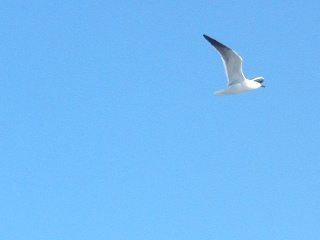How is the weather? The weather appears to be clear and cloudless, with bright blue skies. 